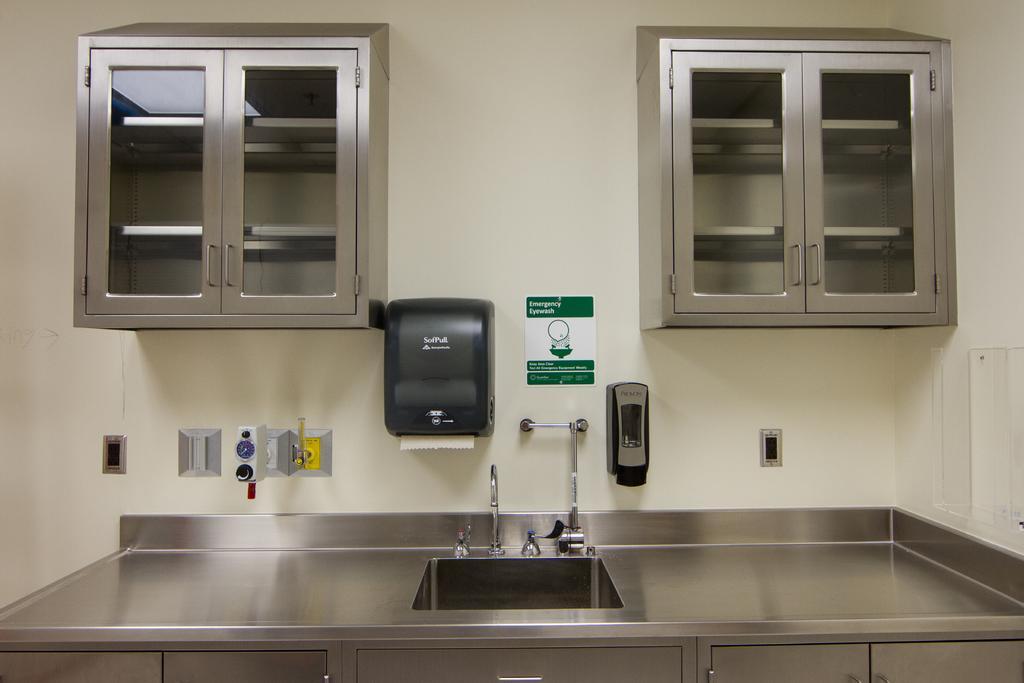In one or two sentences, can you explain what this image depicts? In this image I can see a sink and a water tap in the center. In the background I can see the wall and on it I can see cupboards, a black colour tissue box, a green colour board and few other things. On this board I can see something is written. On the bottom side of this image I can see few more cupboards. 